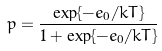Convert formula to latex. <formula><loc_0><loc_0><loc_500><loc_500>p = \frac { \exp \{ - e _ { 0 } / k T \} } { 1 + \exp \{ - e _ { 0 } / k T \} }</formula> 